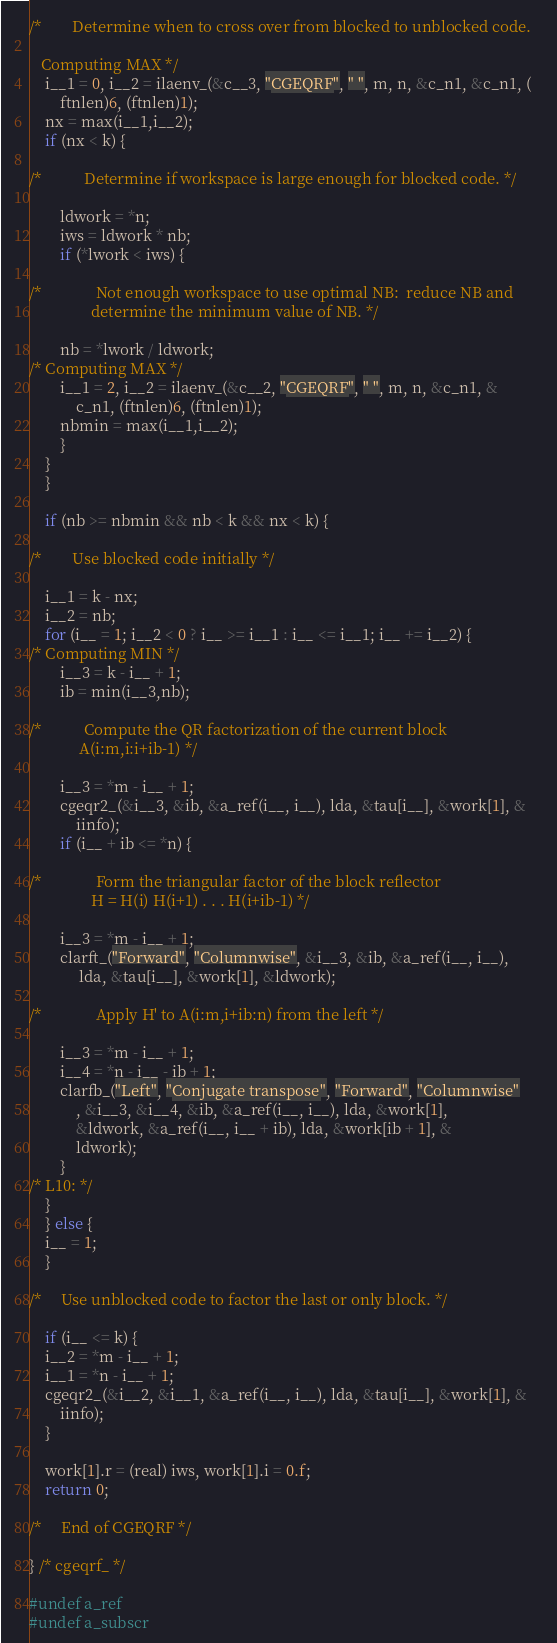<code> <loc_0><loc_0><loc_500><loc_500><_C_>/*        Determine when to cross over from blocked to unblocked code.   

   Computing MAX */
	i__1 = 0, i__2 = ilaenv_(&c__3, "CGEQRF", " ", m, n, &c_n1, &c_n1, (
		ftnlen)6, (ftnlen)1);
	nx = max(i__1,i__2);
	if (nx < k) {

/*           Determine if workspace is large enough for blocked code. */

	    ldwork = *n;
	    iws = ldwork * nb;
	    if (*lwork < iws) {

/*              Not enough workspace to use optimal NB:  reduce NB and   
                determine the minimum value of NB. */

		nb = *lwork / ldwork;
/* Computing MAX */
		i__1 = 2, i__2 = ilaenv_(&c__2, "CGEQRF", " ", m, n, &c_n1, &
			c_n1, (ftnlen)6, (ftnlen)1);
		nbmin = max(i__1,i__2);
	    }
	}
    }

    if (nb >= nbmin && nb < k && nx < k) {

/*        Use blocked code initially */

	i__1 = k - nx;
	i__2 = nb;
	for (i__ = 1; i__2 < 0 ? i__ >= i__1 : i__ <= i__1; i__ += i__2) {
/* Computing MIN */
	    i__3 = k - i__ + 1;
	    ib = min(i__3,nb);

/*           Compute the QR factorization of the current block   
             A(i:m,i:i+ib-1) */

	    i__3 = *m - i__ + 1;
	    cgeqr2_(&i__3, &ib, &a_ref(i__, i__), lda, &tau[i__], &work[1], &
		    iinfo);
	    if (i__ + ib <= *n) {

/*              Form the triangular factor of the block reflector   
                H = H(i) H(i+1) . . . H(i+ib-1) */

		i__3 = *m - i__ + 1;
		clarft_("Forward", "Columnwise", &i__3, &ib, &a_ref(i__, i__),
			 lda, &tau[i__], &work[1], &ldwork);

/*              Apply H' to A(i:m,i+ib:n) from the left */

		i__3 = *m - i__ + 1;
		i__4 = *n - i__ - ib + 1;
		clarfb_("Left", "Conjugate transpose", "Forward", "Columnwise"
			, &i__3, &i__4, &ib, &a_ref(i__, i__), lda, &work[1], 
			&ldwork, &a_ref(i__, i__ + ib), lda, &work[ib + 1], &
			ldwork);
	    }
/* L10: */
	}
    } else {
	i__ = 1;
    }

/*     Use unblocked code to factor the last or only block. */

    if (i__ <= k) {
	i__2 = *m - i__ + 1;
	i__1 = *n - i__ + 1;
	cgeqr2_(&i__2, &i__1, &a_ref(i__, i__), lda, &tau[i__], &work[1], &
		iinfo);
    }

    work[1].r = (real) iws, work[1].i = 0.f;
    return 0;

/*     End of CGEQRF */

} /* cgeqrf_ */

#undef a_ref
#undef a_subscr


</code> 